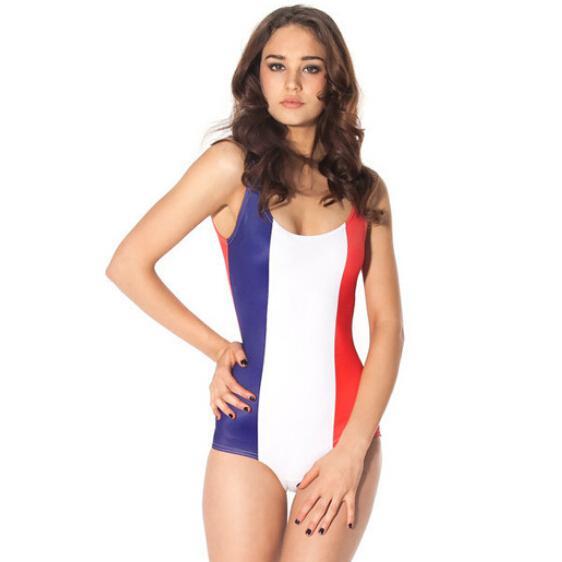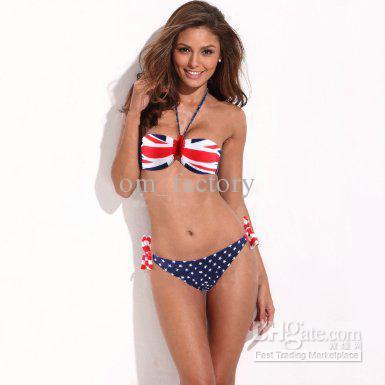The first image is the image on the left, the second image is the image on the right. Assess this claim about the two images: "One woman has her hand on her hip.". Correct or not? Answer yes or no. Yes. The first image is the image on the left, the second image is the image on the right. Examine the images to the left and right. Is the description "At least one model wears a bikini with completely different patterns on the top and bottom." accurate? Answer yes or no. Yes. 